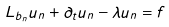<formula> <loc_0><loc_0><loc_500><loc_500>L _ { b _ { n } } u _ { n } + \partial _ { t } u _ { n } - \lambda u _ { n } = f</formula> 